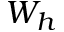<formula> <loc_0><loc_0><loc_500><loc_500>W _ { h }</formula> 